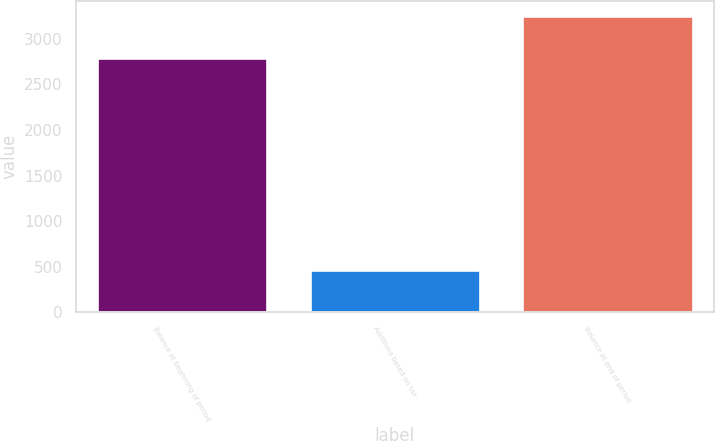Convert chart. <chart><loc_0><loc_0><loc_500><loc_500><bar_chart><fcel>Balance at beginning of period<fcel>Additions based on tax<fcel>Balance at end of period<nl><fcel>2784<fcel>469<fcel>3253<nl></chart> 